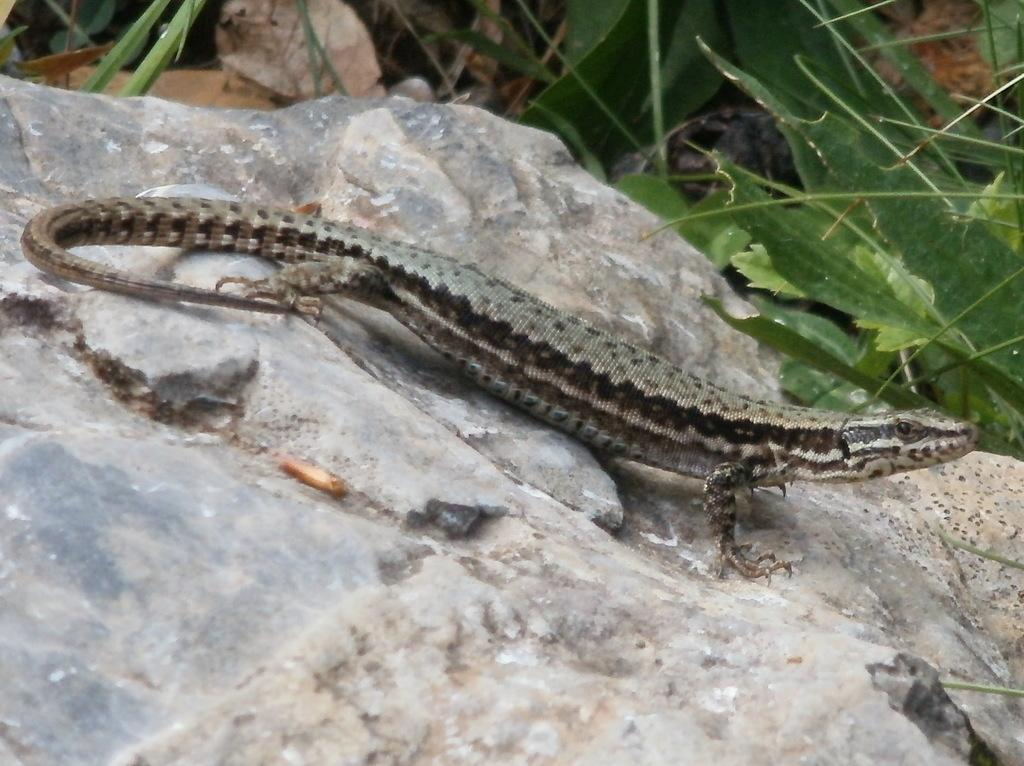What type of animal is in the image? There is an alligator lizard in the image. What is the alligator lizard resting on? The alligator lizard is on a stone surface. What type of vegetation can be seen in the image? There are plants visible at the top and right side of the image. What type of scarecrow is present in the image? There is no scarecrow present in the image. How many points does the alligator lizard have in the image? The alligator lizard does not have points; it is a reptile with a distinct body shape. 